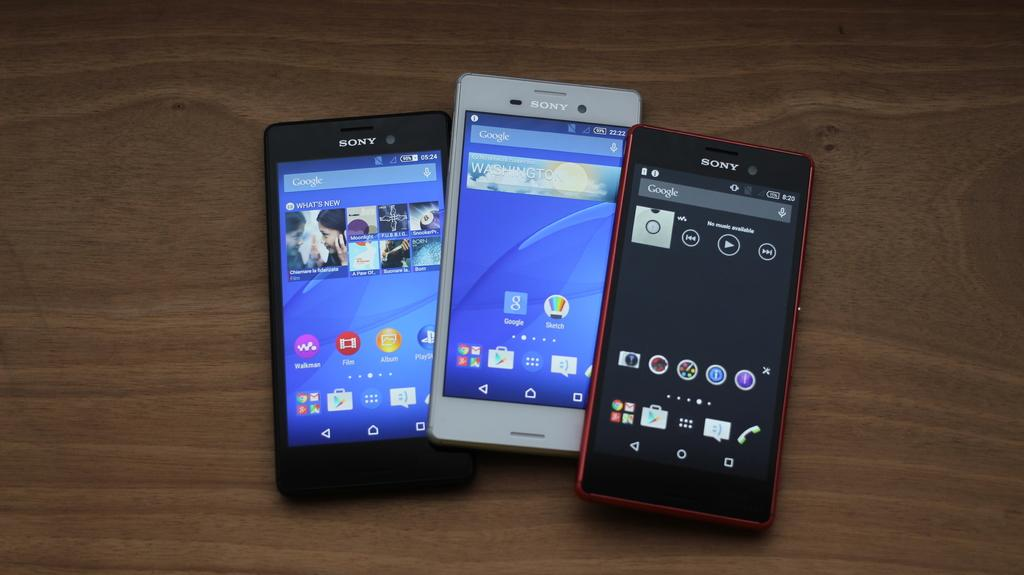<image>
Present a compact description of the photo's key features. three phones with one that has a Google icon on it 